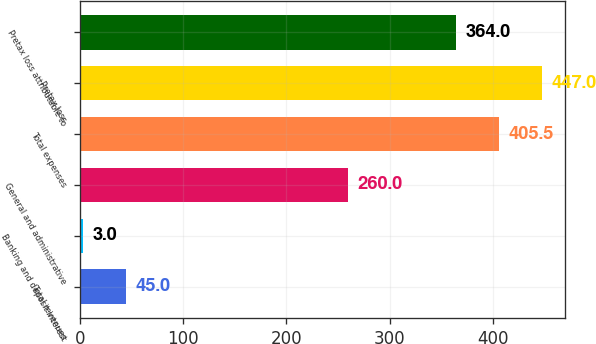Convert chart. <chart><loc_0><loc_0><loc_500><loc_500><bar_chart><fcel>Total revenues<fcel>Banking and deposit interest<fcel>General and administrative<fcel>Total expenses<fcel>Pretax loss<fcel>Pretax loss attributable to<nl><fcel>45<fcel>3<fcel>260<fcel>405.5<fcel>447<fcel>364<nl></chart> 